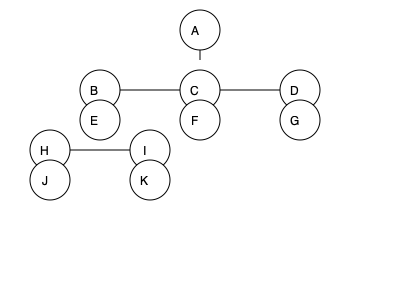Based on the family tree diagram representing a matrilineal society, what type of kinship structure is depicted, and how does it differ from a patrilineal system? To identify the kinship structure and compare it to a patrilineal system, we need to analyze the diagram step-by-step:

1. Observe the structure: The diagram shows multiple generations with a single individual (A) at the top, branching out to lower generations.

2. Identify the descent pattern:
   - B, C, and D are likely siblings or cousins in the same generation.
   - E, F, and G are the children of B, C, and D respectively.
   - H and I are the children of E.
   - J and K are the children of H and I respectively.

3. Recognize the matrilineal pattern:
   - The lineage is traced through the female line.
   - Each generation shows the children of the females from the previous generation.

4. Compare to a patrilineal system:
   - In a patrilineal system, descent would be traced through the male line.
   - Children would belong to their father's lineage rather than their mother's.

5. Key differences:
   - Inheritance and group membership in matrilineal societies pass through the mother's line.
   - In patrilineal societies, these would pass through the father's line.
   - Matrilineal systems often emphasize the importance of maternal uncles in child-rearing and social structure.

6. Cultural implications:
   - Matrilineal societies often have different power structures and social organizations compared to patrilineal ones.
   - Women in matrilineal societies may have more autonomy and social influence.

This diagram represents a matrilineal kinship structure, where descent and inheritance are traced through the female line, contrasting with patrilineal systems where these are traced through the male line.
Answer: Matrilineal kinship structure 